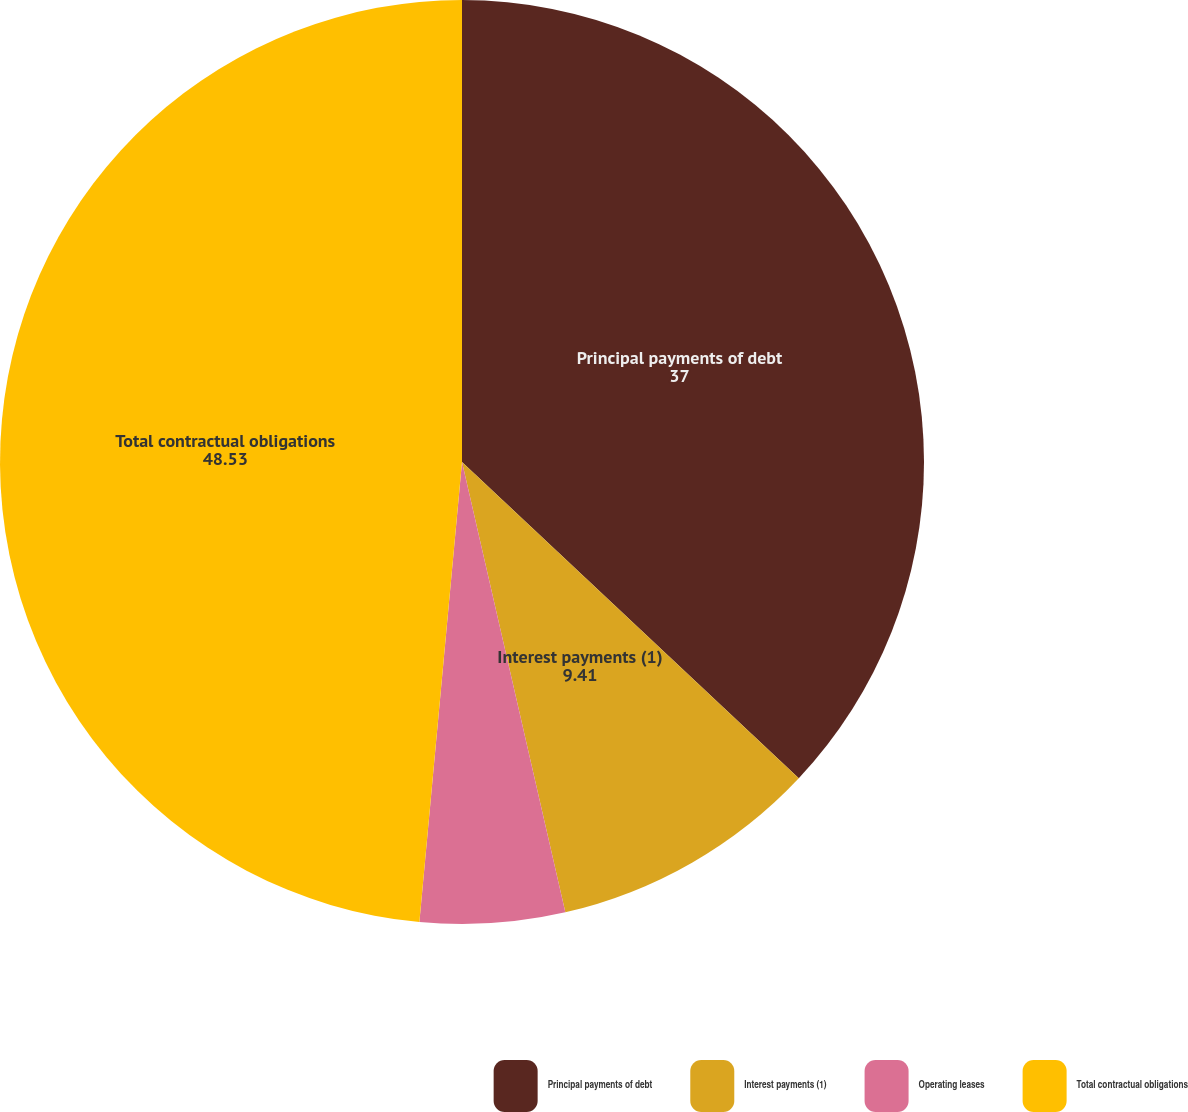<chart> <loc_0><loc_0><loc_500><loc_500><pie_chart><fcel>Principal payments of debt<fcel>Interest payments (1)<fcel>Operating leases<fcel>Total contractual obligations<nl><fcel>37.0%<fcel>9.41%<fcel>5.06%<fcel>48.53%<nl></chart> 